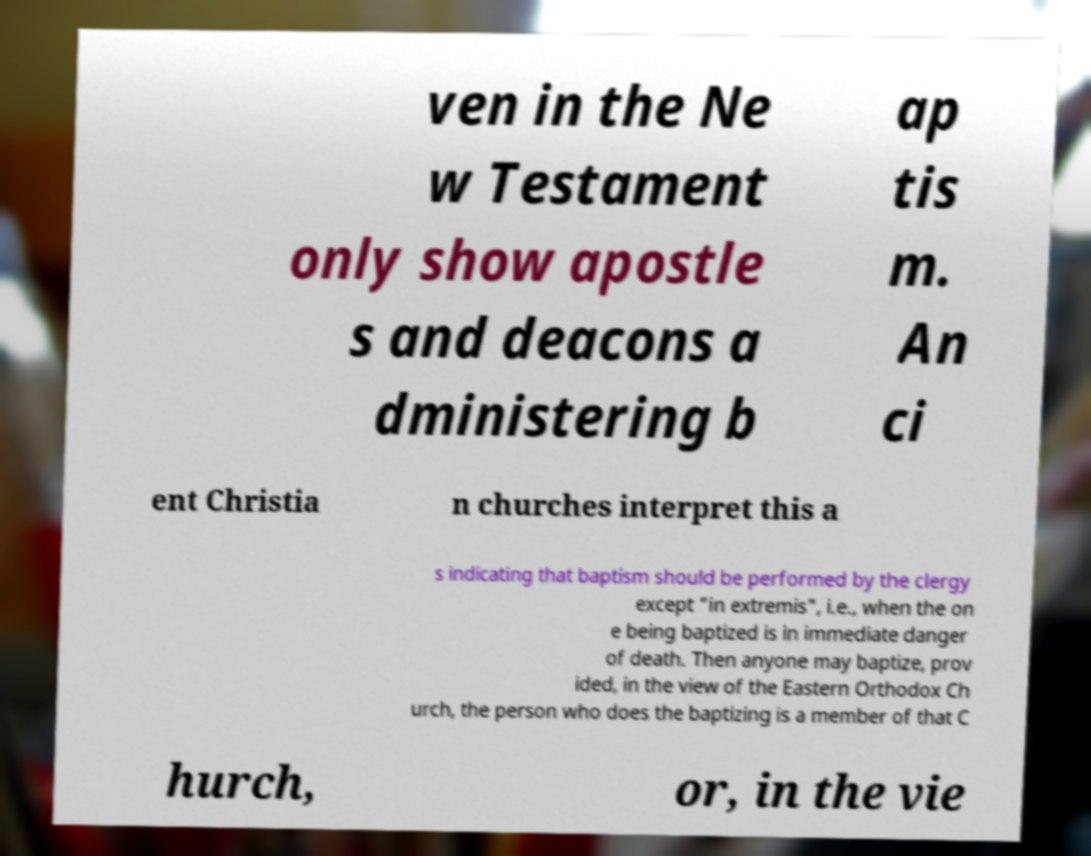Please identify and transcribe the text found in this image. ven in the Ne w Testament only show apostle s and deacons a dministering b ap tis m. An ci ent Christia n churches interpret this a s indicating that baptism should be performed by the clergy except "in extremis", i.e., when the on e being baptized is in immediate danger of death. Then anyone may baptize, prov ided, in the view of the Eastern Orthodox Ch urch, the person who does the baptizing is a member of that C hurch, or, in the vie 